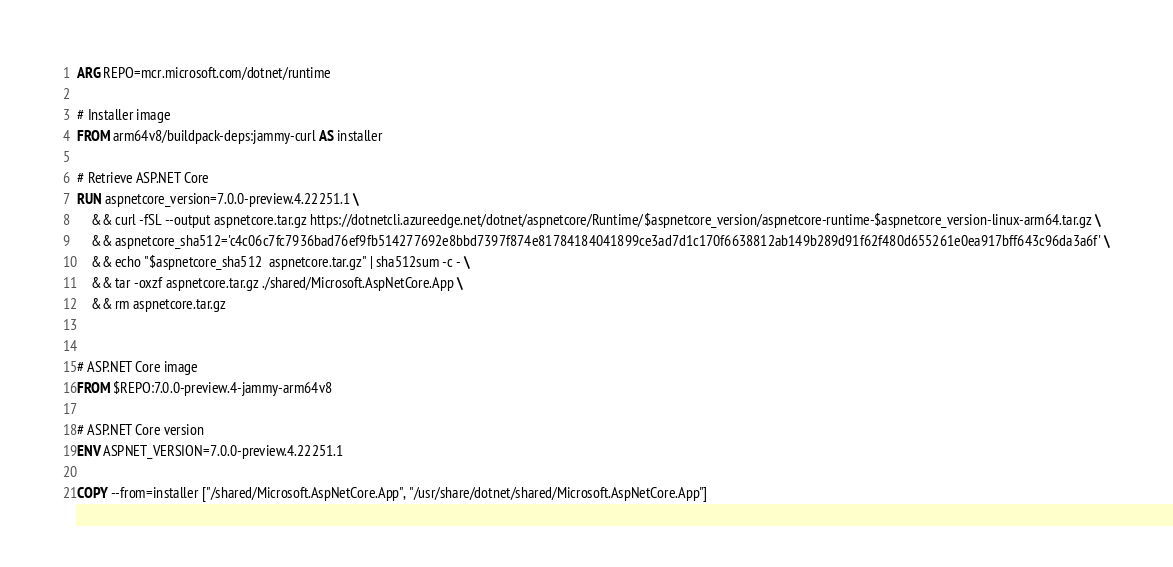<code> <loc_0><loc_0><loc_500><loc_500><_Dockerfile_>ARG REPO=mcr.microsoft.com/dotnet/runtime

# Installer image
FROM arm64v8/buildpack-deps:jammy-curl AS installer

# Retrieve ASP.NET Core
RUN aspnetcore_version=7.0.0-preview.4.22251.1 \
    && curl -fSL --output aspnetcore.tar.gz https://dotnetcli.azureedge.net/dotnet/aspnetcore/Runtime/$aspnetcore_version/aspnetcore-runtime-$aspnetcore_version-linux-arm64.tar.gz \
    && aspnetcore_sha512='c4c06c7fc7936bad76ef9fb514277692e8bbd7397f874e81784184041899ce3ad7d1c170f6638812ab149b289d91f62f480d655261e0ea917bff643c96da3a6f' \
    && echo "$aspnetcore_sha512  aspnetcore.tar.gz" | sha512sum -c - \
    && tar -oxzf aspnetcore.tar.gz ./shared/Microsoft.AspNetCore.App \
    && rm aspnetcore.tar.gz


# ASP.NET Core image
FROM $REPO:7.0.0-preview.4-jammy-arm64v8

# ASP.NET Core version
ENV ASPNET_VERSION=7.0.0-preview.4.22251.1

COPY --from=installer ["/shared/Microsoft.AspNetCore.App", "/usr/share/dotnet/shared/Microsoft.AspNetCore.App"]
</code> 